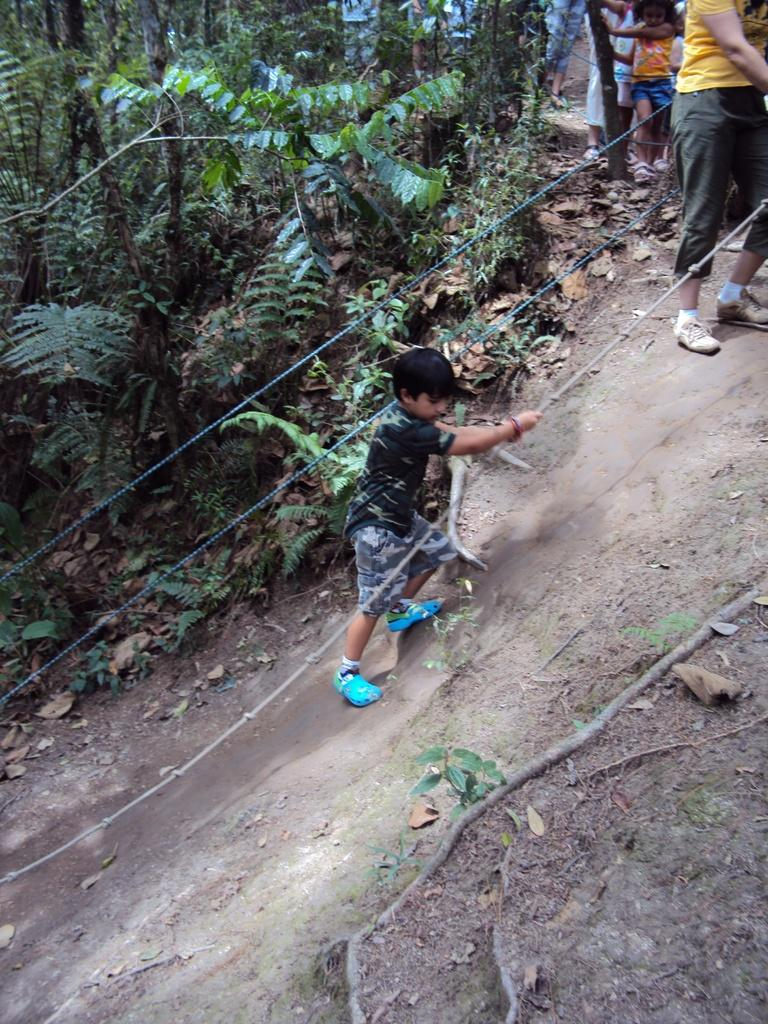Who or what can be seen in the image? There are people in the image. What type of natural elements are present in the image? There are trees and plants in the image. Where is the cave located in the image? There is no cave present in the image. What season is depicted in the image, considering the presence of falling leaves? The image does not show any falling leaves, so it is not possible to determine the season. 